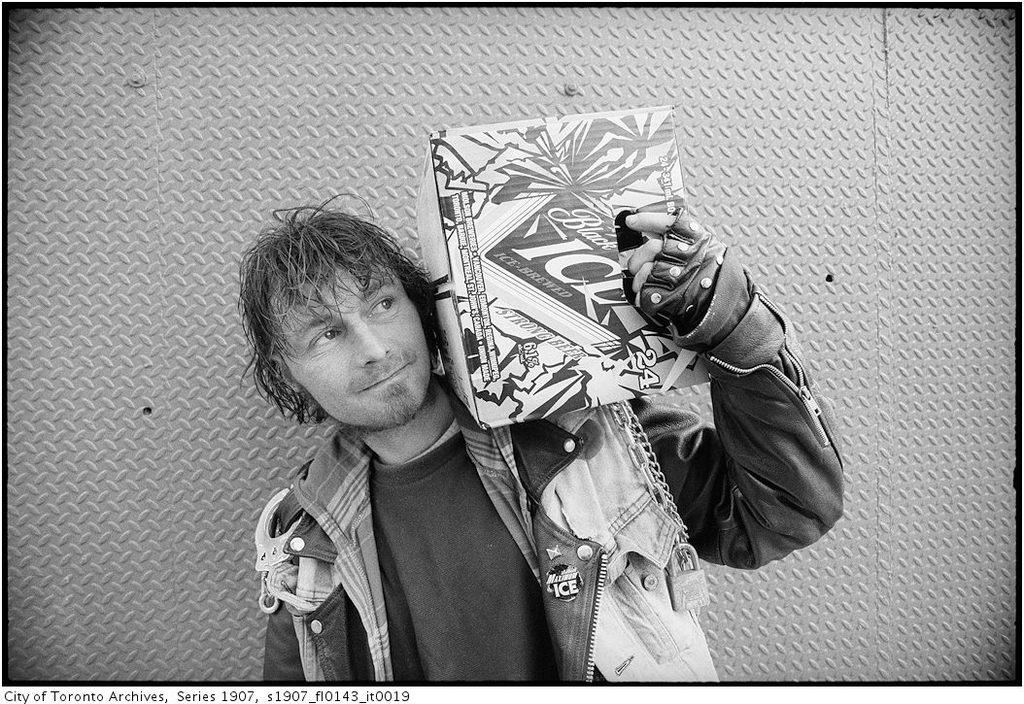What is the main subject of the picture? The main subject of the picture is a man. What is the man wearing on his upper body? The man is wearing a jacket and a t-shirt. What is the man wearing on his hands? The man is wearing gloves. What is the man holding in the picture? The man is holding a cotton box. What is located beside the man in the image? There is a wall beside the man. What type of food is the man eating in the picture? There is no food visible in the image, and the man is not shown eating anything. What is the man learning in the picture? There is no indication in the image that the man is learning anything. Can you see a donkey in the picture? No, there is no donkey present in the image. 